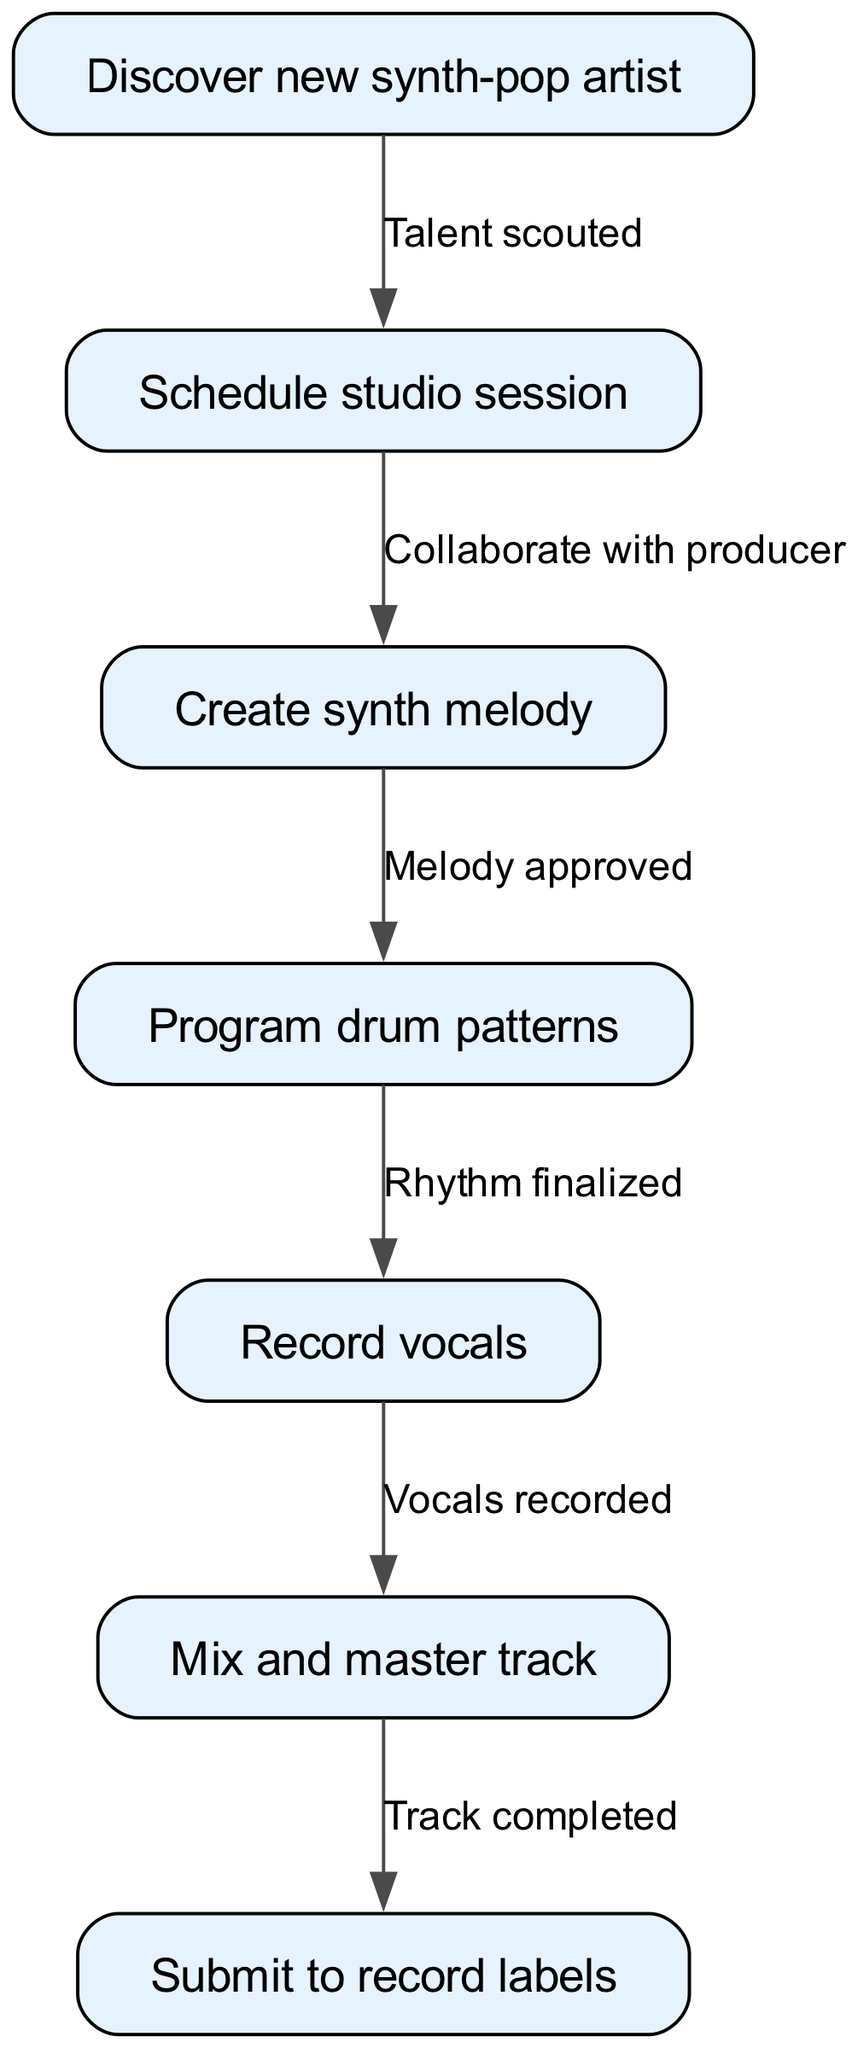what's the total number of nodes in the diagram? The diagram includes a list of nodes that specify different steps in the music production workflow. By counting all nodes specified (Discover new synth-pop artist, Schedule studio session, Create synth melody, Program drum patterns, Record vocals, Mix and master track, Submit to record labels), we find there are seven nodes in total.
Answer: 7 what is the relationship between "Discover new synth-pop artist" and "Schedule studio session"? The edge connecting these nodes indicates that when a talent is scouted, the next step in the workflow is to schedule a studio session. The directed flow from the first node to the second defines this relationship.
Answer: Talent scouted how many steps are there in the workflow from start to finish? To determine the total steps in the workflow, we need to follow the edges from the first node all the way to the last one. The path includes seven distinct actions, which signifies there are six transitions. Hence, including the starting point, there are seven steps in total.
Answer: 7 what comes after "Mix and master track" in the workflow? The diagram indicates a direct flow from the step "Mix and master track" to "Submit to record labels." By identifying the edge leading out of the sixth node, we can see that this is the next action following the completion of mixing and mastering.
Answer: Submit to record labels what is needed before "Record vocals"? The edge leading to the "Record vocals" node originates from "Program drum patterns." This shows that finalizing the rhythm, as indicated in the previous node, is a prerequisite action before recording the vocals can take place, establishing the necessary conditions for this step.
Answer: Rhythm finalized what is the final action in the music production workflow? The last node in the diagram is "Submit to record labels," indicating that once the track has been mixed and mastered, the final action involves submitting the completed track to record labels for consideration. This can be seen clearly as the endpoint of the workflow.
Answer: Submit to record labels how many edges are in the diagram? Each edge represents a direct pathway between nodes, outlining the flow of actions in the music production process. By counting the edges shown in the diagram, we find there are six connections between the nodes altogether, as each action is connected sequentially to allow for the workflow to progress.
Answer: 6 which node represents creating melody? By reviewing the nodes in the diagram, we can identify "Create synth melody" as the specific node dedicated to that action in the workflow. It is the third node in the sequence, clearly labeled to represent this task.
Answer: Create synth melody 